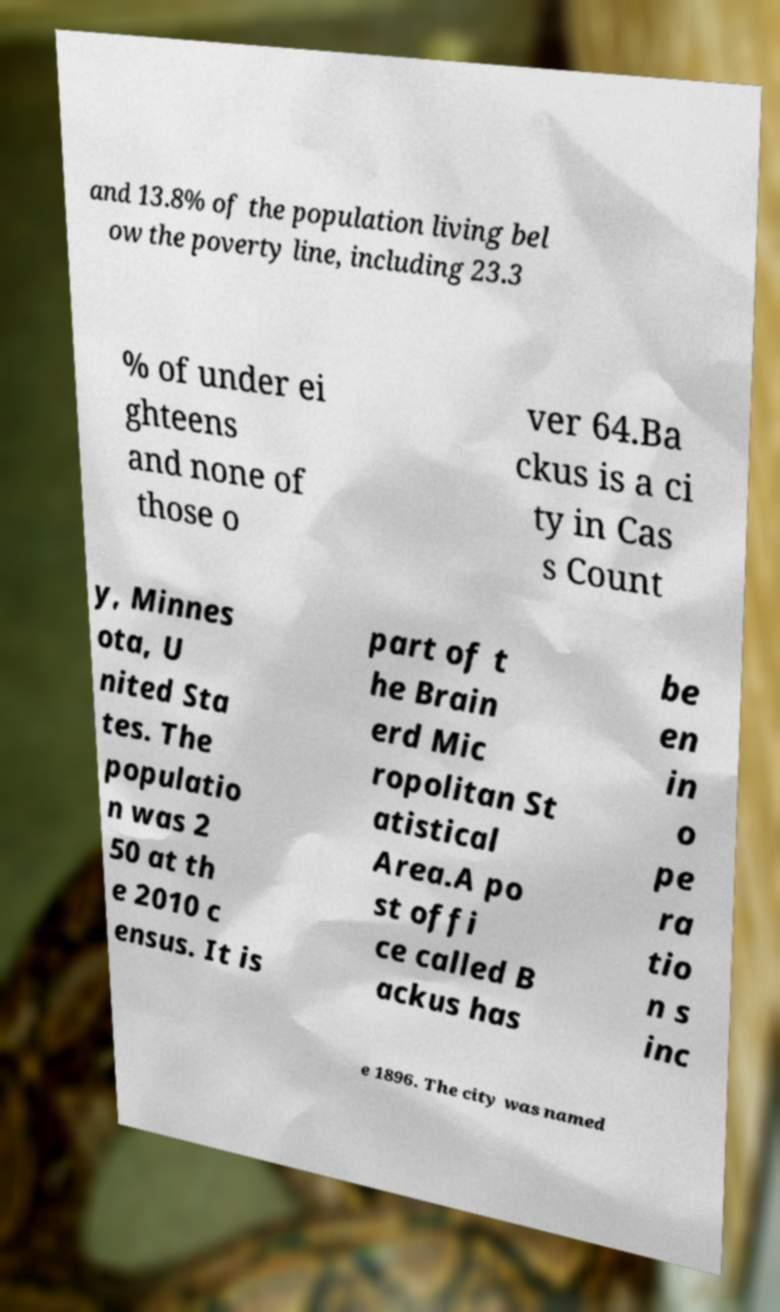What messages or text are displayed in this image? I need them in a readable, typed format. and 13.8% of the population living bel ow the poverty line, including 23.3 % of under ei ghteens and none of those o ver 64.Ba ckus is a ci ty in Cas s Count y, Minnes ota, U nited Sta tes. The populatio n was 2 50 at th e 2010 c ensus. It is part of t he Brain erd Mic ropolitan St atistical Area.A po st offi ce called B ackus has be en in o pe ra tio n s inc e 1896. The city was named 